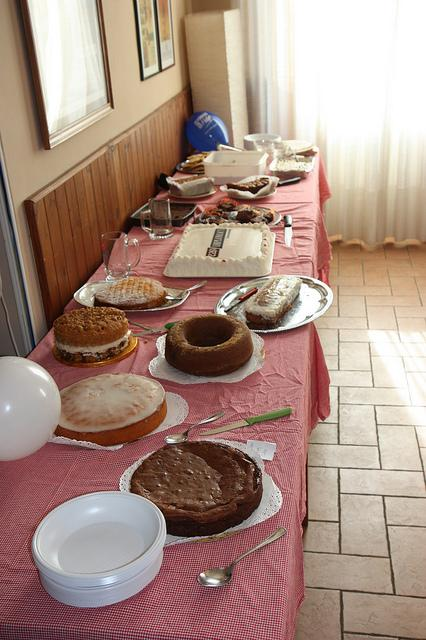How many cakes needed to cool down before adding a creamy glaze to it? three 